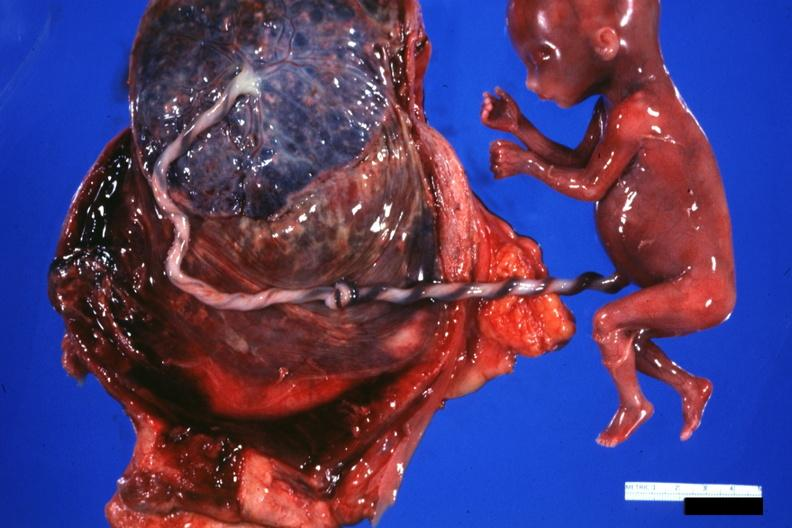how does this image show fetus cord?
Answer the question using a single word or phrase. With knot and placenta 